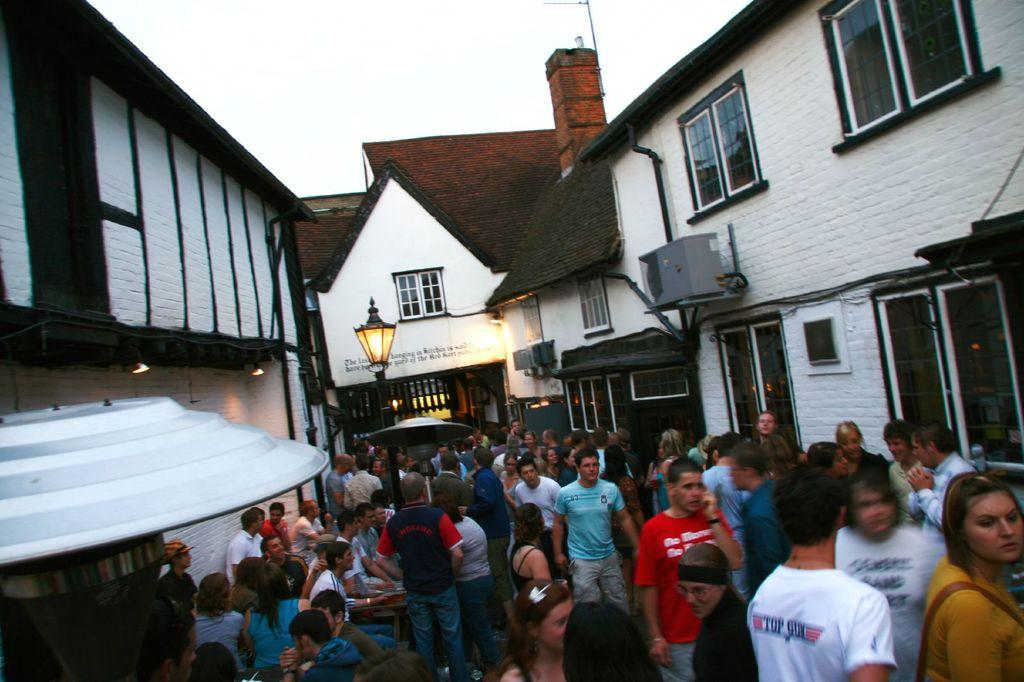What type of structures can be seen in the image? There are houses in the image. What type of lighting is present in the image? There is a street lamp in the image. Are there any living beings visible in the image? Yes, there are people visible in the image. What is visible at the top of the image? The sky is visible at the top of the image. What type of cork can be seen in the image? There is no cork present in the image. What type of trade is being conducted in the image? There is no trade being conducted in the image. 